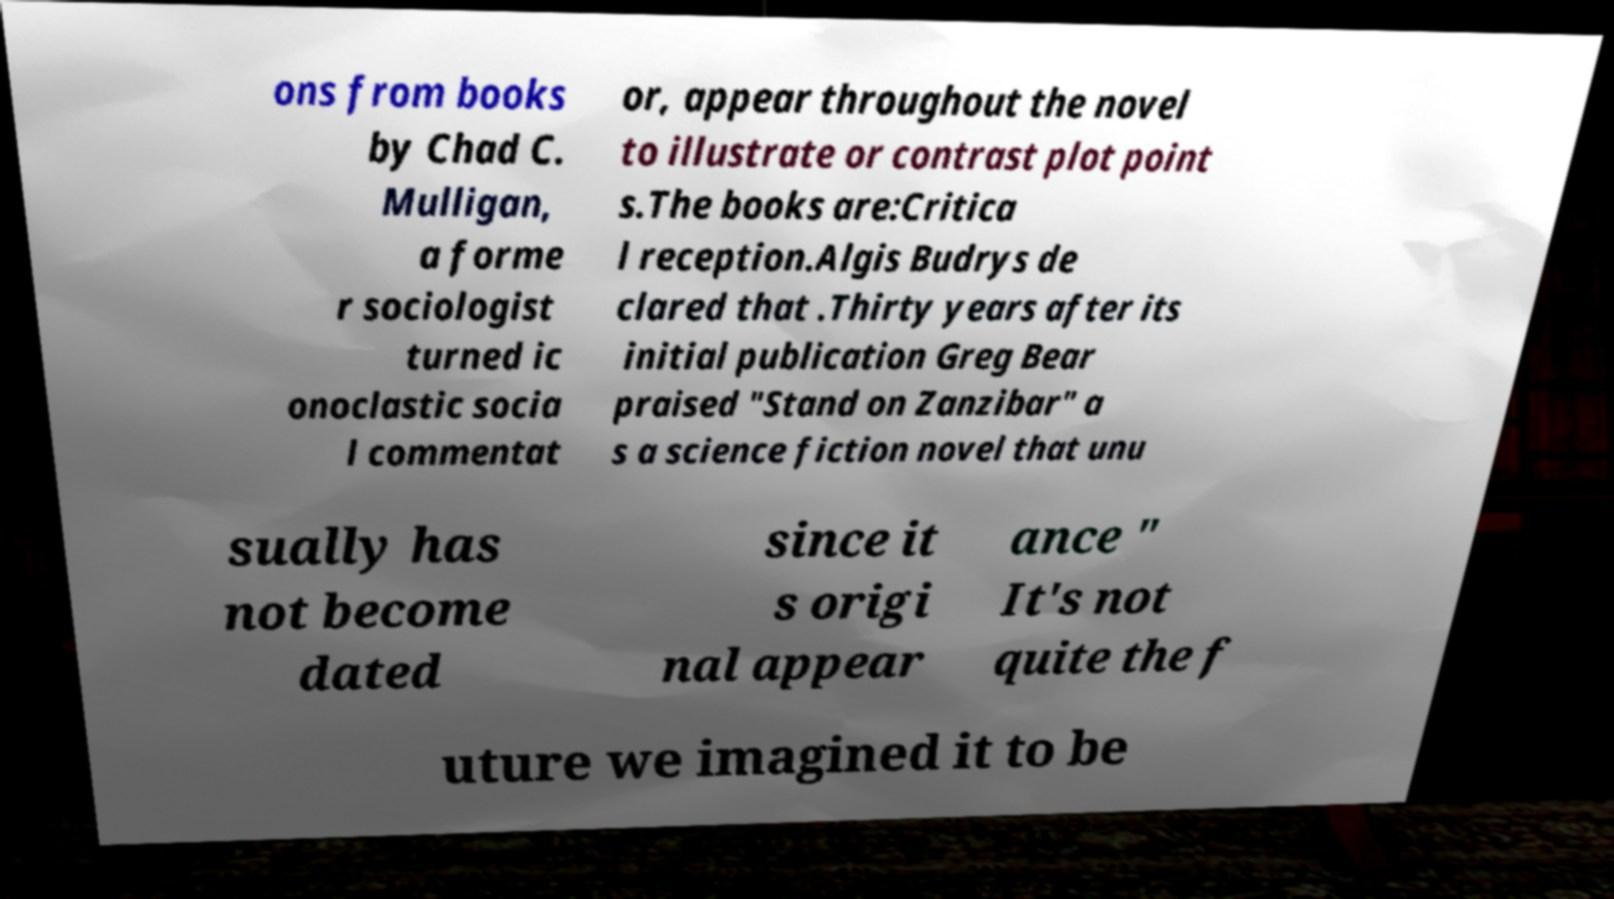Please identify and transcribe the text found in this image. ons from books by Chad C. Mulligan, a forme r sociologist turned ic onoclastic socia l commentat or, appear throughout the novel to illustrate or contrast plot point s.The books are:Critica l reception.Algis Budrys de clared that .Thirty years after its initial publication Greg Bear praised "Stand on Zanzibar" a s a science fiction novel that unu sually has not become dated since it s origi nal appear ance " It's not quite the f uture we imagined it to be 